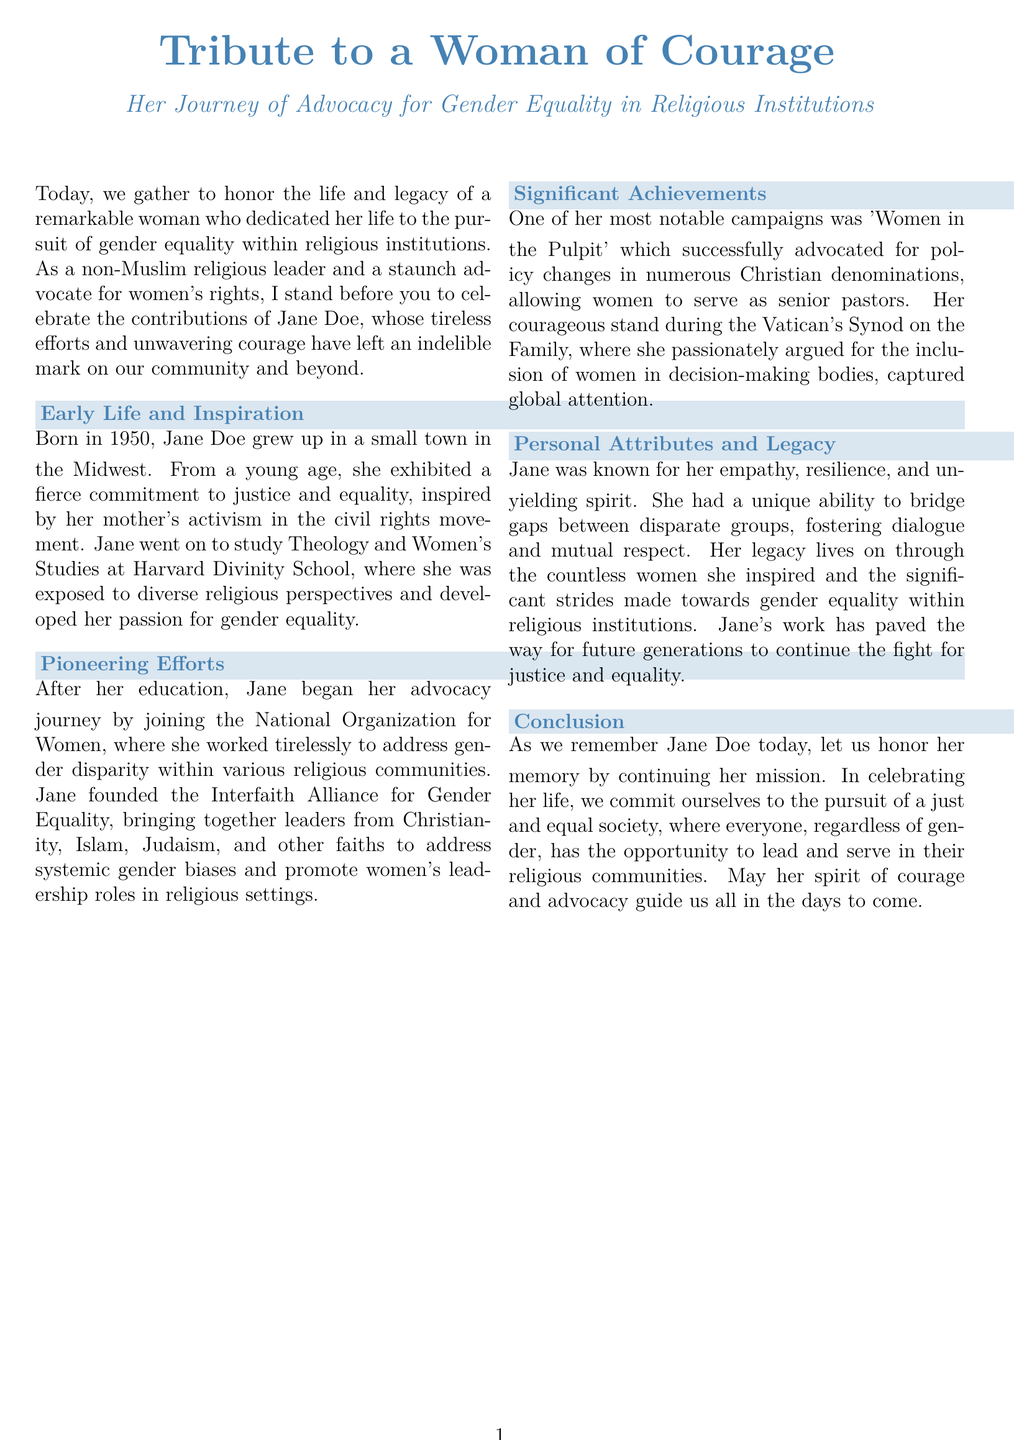What is the name of the woman being honored? The document specifically names Jane Doe as the woman being honored for her contributions.
Answer: Jane Doe In what year was Jane Doe born? The document states Jane Doe was born in 1950.
Answer: 1950 What organization did Jane join to start her advocacy work? The document mentions that she joined the National Organization for Women to begin her advocacy efforts.
Answer: National Organization for Women What was one of Jane's notable campaigns? According to the document, her campaign 'Women in the Pulpit' was one of her most notable efforts for advocacy.
Answer: Women in the Pulpit What degree did Jane pursue at Harvard Divinity School? The document states that Jane studied Theology and Women's Studies at Harvard Divinity School.
Answer: Theology and Women's Studies Which religious settings did Jane advocate for regarding leadership roles? The document indicates that she worked to promote women's leadership roles in various religious communities.
Answer: Religious communities What personal attribute was Jane particularly known for? The document highlights Jane's empathy as one of her key personal attributes.
Answer: Empathy What is a key commitment we make in Jane's memory? The document emphasizes the commitment to the pursuit of a just and equal society in her memory.
Answer: Just and equal society Which interfaith organization did Jane found? The document notes that she founded the Interfaith Alliance for Gender Equality.
Answer: Interfaith Alliance for Gender Equality 